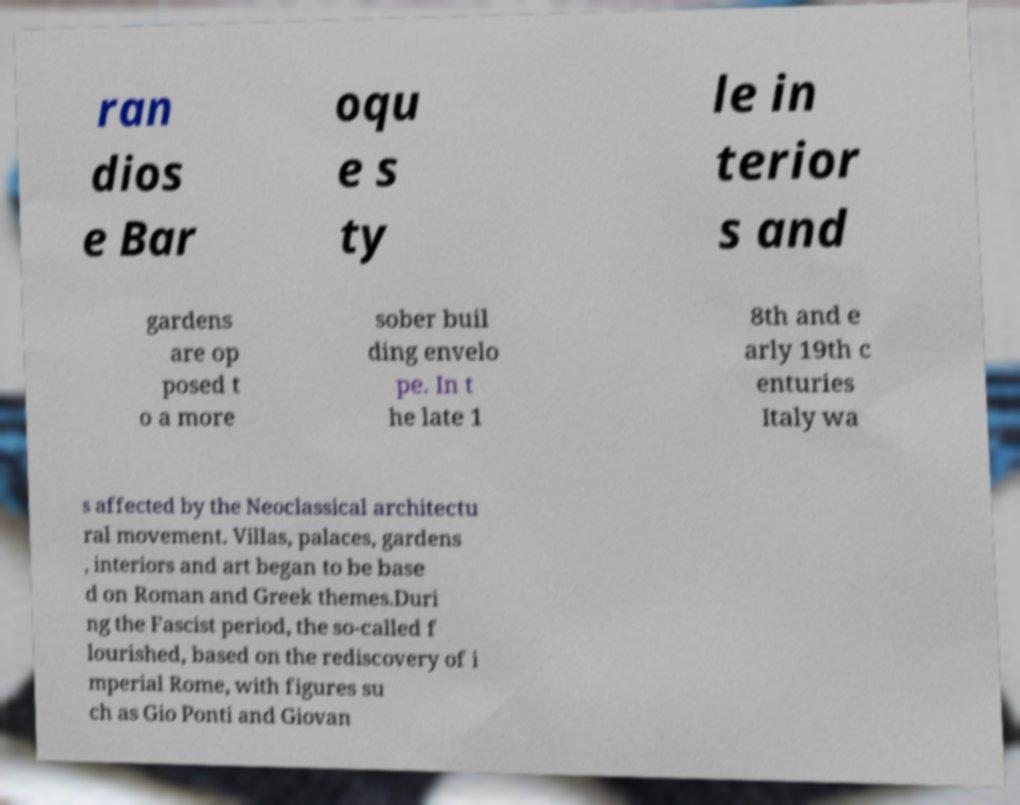What messages or text are displayed in this image? I need them in a readable, typed format. ran dios e Bar oqu e s ty le in terior s and gardens are op posed t o a more sober buil ding envelo pe. In t he late 1 8th and e arly 19th c enturies Italy wa s affected by the Neoclassical architectu ral movement. Villas, palaces, gardens , interiors and art began to be base d on Roman and Greek themes.Duri ng the Fascist period, the so-called f lourished, based on the rediscovery of i mperial Rome, with figures su ch as Gio Ponti and Giovan 